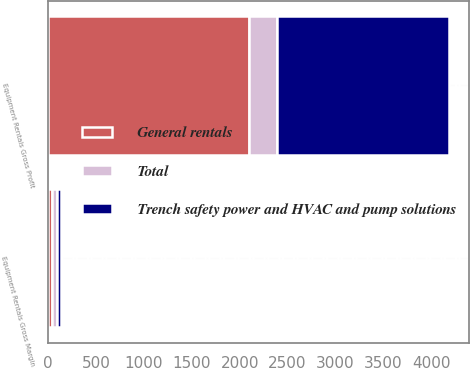Convert chart to OTSL. <chart><loc_0><loc_0><loc_500><loc_500><stacked_bar_chart><ecel><fcel>Equipment Rentals Gross Profit<fcel>Equipment Rentals Gross Margin<nl><fcel>Trench safety power and HVAC and pump solutions<fcel>1790<fcel>42.4<nl><fcel>Total<fcel>302<fcel>50.6<nl><fcel>General rentals<fcel>2092<fcel>43.4<nl></chart> 